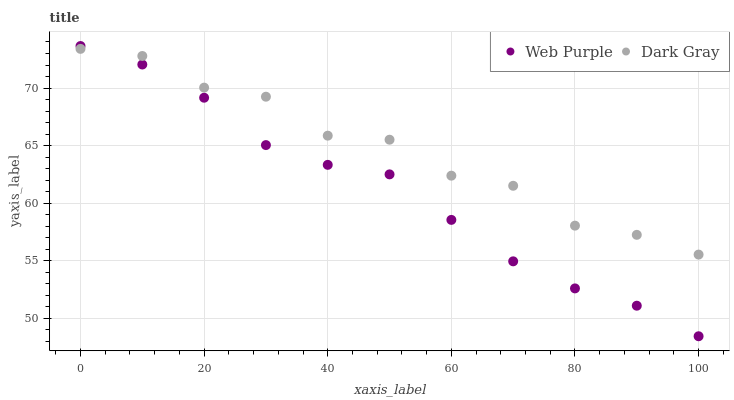Does Web Purple have the minimum area under the curve?
Answer yes or no. Yes. Does Dark Gray have the maximum area under the curve?
Answer yes or no. Yes. Does Web Purple have the maximum area under the curve?
Answer yes or no. No. Is Web Purple the smoothest?
Answer yes or no. Yes. Is Dark Gray the roughest?
Answer yes or no. Yes. Is Web Purple the roughest?
Answer yes or no. No. Does Web Purple have the lowest value?
Answer yes or no. Yes. Does Web Purple have the highest value?
Answer yes or no. Yes. Does Dark Gray intersect Web Purple?
Answer yes or no. Yes. Is Dark Gray less than Web Purple?
Answer yes or no. No. Is Dark Gray greater than Web Purple?
Answer yes or no. No. 